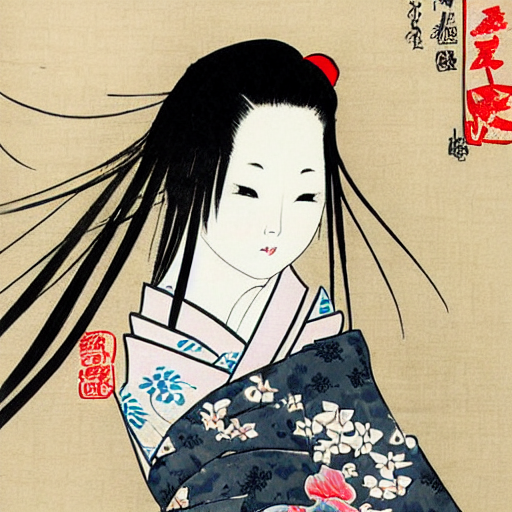This character seems thoughtful or introspective. What might they be thinking about? While interpreting the thoughts of a character in a print requires us to imagine, one could surmise that the introspective gaze and poised demeanor might reflect a moment of contemplation or silent communication with the audience. The actor's performance artistry is captured in this still representation, possibly conveying the emotional subtext of a scene from a Kabuki play, which often involves complex social and romantic themes. The subtlety of the character's expression invites viewers to ponder the inner narrative and emotions behind the restrained façade. 